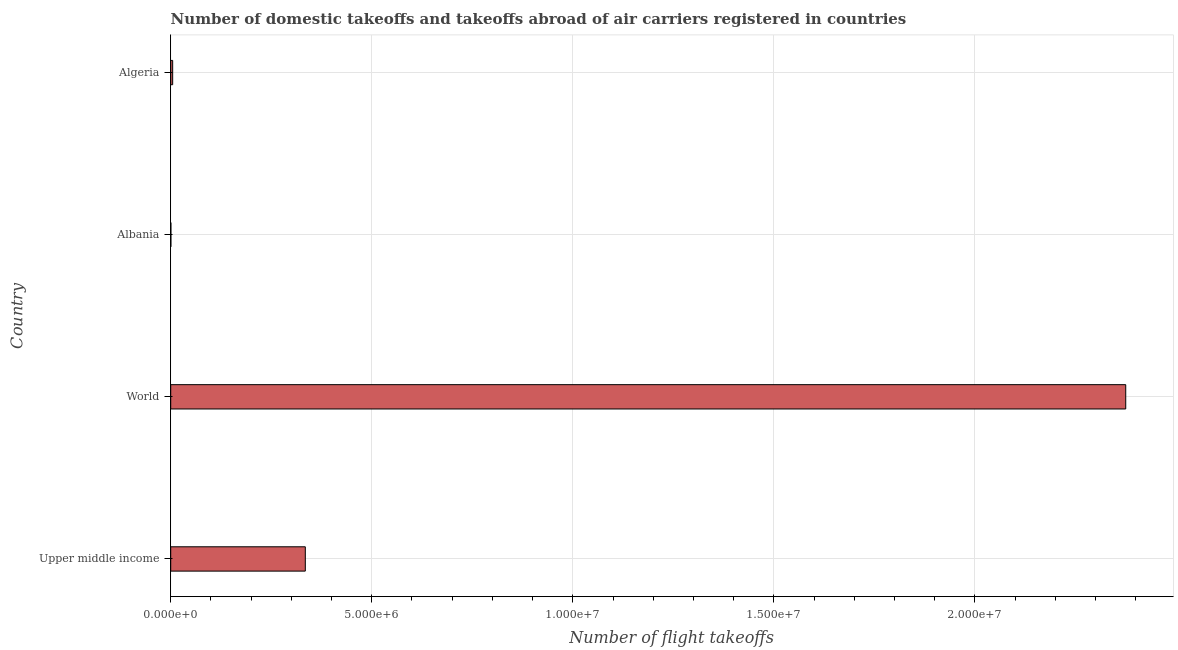Does the graph contain any zero values?
Your response must be concise. No. What is the title of the graph?
Keep it short and to the point. Number of domestic takeoffs and takeoffs abroad of air carriers registered in countries. What is the label or title of the X-axis?
Provide a short and direct response. Number of flight takeoffs. What is the label or title of the Y-axis?
Provide a succinct answer. Country. What is the number of flight takeoffs in Upper middle income?
Your answer should be very brief. 3.35e+06. Across all countries, what is the maximum number of flight takeoffs?
Offer a very short reply. 2.38e+07. Across all countries, what is the minimum number of flight takeoffs?
Offer a very short reply. 4104. In which country was the number of flight takeoffs maximum?
Provide a short and direct response. World. In which country was the number of flight takeoffs minimum?
Ensure brevity in your answer.  Albania. What is the sum of the number of flight takeoffs?
Offer a very short reply. 2.72e+07. What is the difference between the number of flight takeoffs in Albania and Upper middle income?
Provide a short and direct response. -3.34e+06. What is the average number of flight takeoffs per country?
Give a very brief answer. 6.79e+06. What is the median number of flight takeoffs?
Provide a short and direct response. 1.70e+06. In how many countries, is the number of flight takeoffs greater than 4000000 ?
Provide a short and direct response. 1. What is the ratio of the number of flight takeoffs in Albania to that in Algeria?
Offer a very short reply. 0.09. Is the number of flight takeoffs in Albania less than that in World?
Keep it short and to the point. Yes. What is the difference between the highest and the second highest number of flight takeoffs?
Provide a short and direct response. 2.04e+07. What is the difference between the highest and the lowest number of flight takeoffs?
Keep it short and to the point. 2.37e+07. In how many countries, is the number of flight takeoffs greater than the average number of flight takeoffs taken over all countries?
Your answer should be compact. 1. How many bars are there?
Your answer should be very brief. 4. Are all the bars in the graph horizontal?
Keep it short and to the point. Yes. How many countries are there in the graph?
Make the answer very short. 4. Are the values on the major ticks of X-axis written in scientific E-notation?
Ensure brevity in your answer.  Yes. What is the Number of flight takeoffs of Upper middle income?
Provide a short and direct response. 3.35e+06. What is the Number of flight takeoffs of World?
Ensure brevity in your answer.  2.38e+07. What is the Number of flight takeoffs of Albania?
Give a very brief answer. 4104. What is the Number of flight takeoffs of Algeria?
Your answer should be very brief. 4.85e+04. What is the difference between the Number of flight takeoffs in Upper middle income and World?
Give a very brief answer. -2.04e+07. What is the difference between the Number of flight takeoffs in Upper middle income and Albania?
Provide a succinct answer. 3.34e+06. What is the difference between the Number of flight takeoffs in Upper middle income and Algeria?
Make the answer very short. 3.30e+06. What is the difference between the Number of flight takeoffs in World and Albania?
Give a very brief answer. 2.37e+07. What is the difference between the Number of flight takeoffs in World and Algeria?
Give a very brief answer. 2.37e+07. What is the difference between the Number of flight takeoffs in Albania and Algeria?
Offer a very short reply. -4.44e+04. What is the ratio of the Number of flight takeoffs in Upper middle income to that in World?
Give a very brief answer. 0.14. What is the ratio of the Number of flight takeoffs in Upper middle income to that in Albania?
Offer a very short reply. 815.66. What is the ratio of the Number of flight takeoffs in Upper middle income to that in Algeria?
Provide a short and direct response. 68.98. What is the ratio of the Number of flight takeoffs in World to that in Albania?
Your answer should be very brief. 5787.67. What is the ratio of the Number of flight takeoffs in World to that in Algeria?
Ensure brevity in your answer.  489.43. What is the ratio of the Number of flight takeoffs in Albania to that in Algeria?
Your response must be concise. 0.09. 